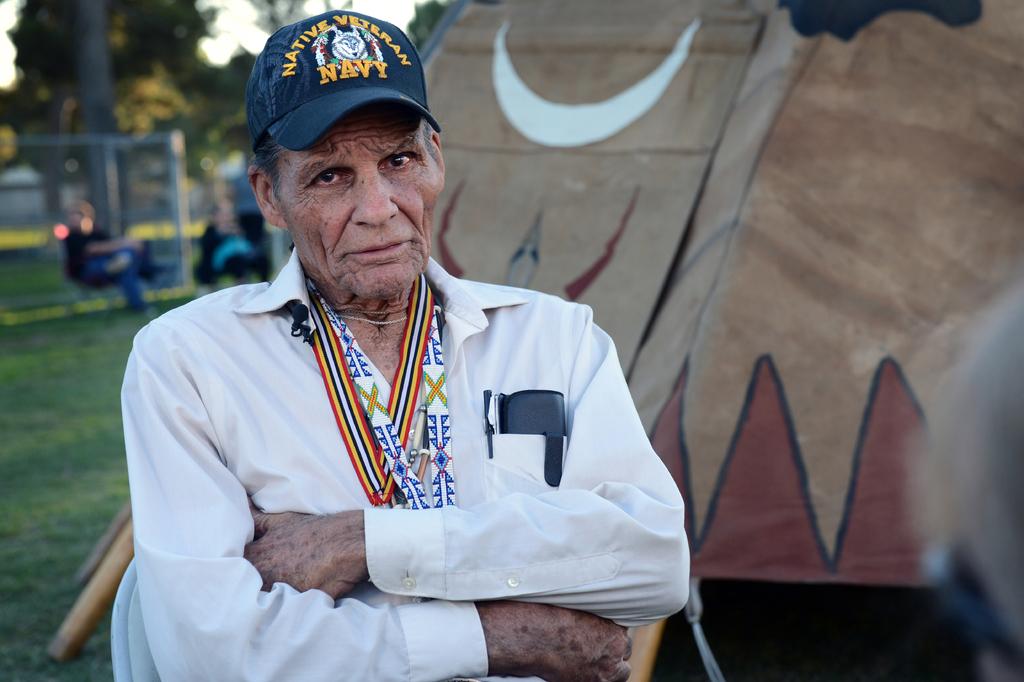What branch of the armed services is shown on the man's hat?
Offer a very short reply. Navy. What kind of veteran is this man?
Offer a terse response. Navy. 